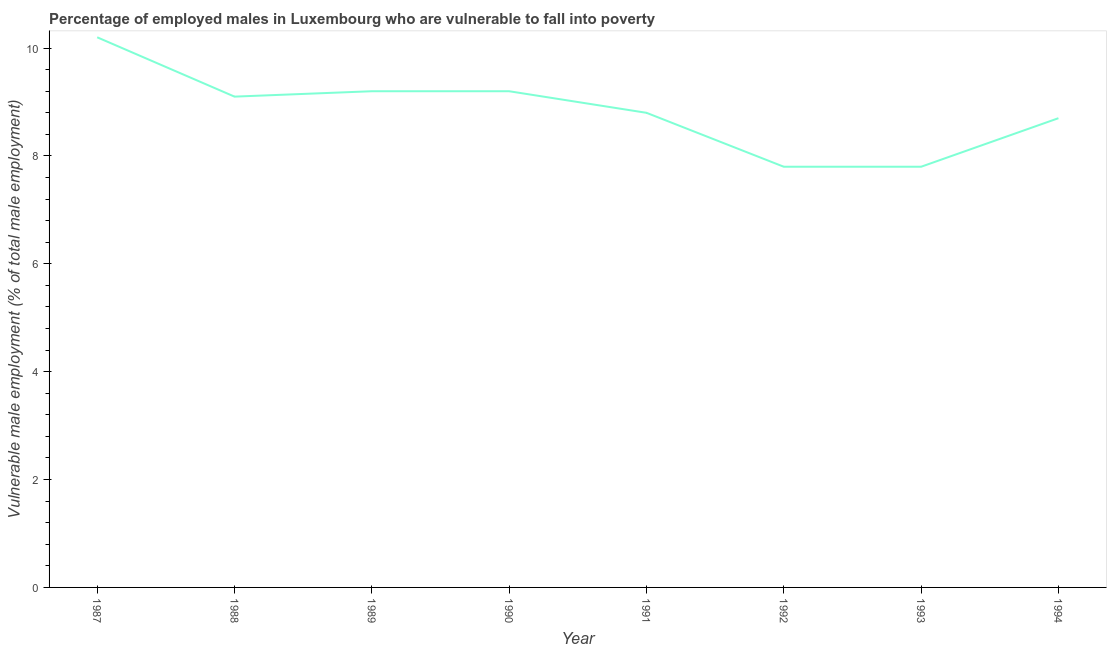What is the percentage of employed males who are vulnerable to fall into poverty in 1989?
Provide a short and direct response. 9.2. Across all years, what is the maximum percentage of employed males who are vulnerable to fall into poverty?
Ensure brevity in your answer.  10.2. Across all years, what is the minimum percentage of employed males who are vulnerable to fall into poverty?
Give a very brief answer. 7.8. In which year was the percentage of employed males who are vulnerable to fall into poverty maximum?
Provide a succinct answer. 1987. What is the sum of the percentage of employed males who are vulnerable to fall into poverty?
Your answer should be compact. 70.8. What is the difference between the percentage of employed males who are vulnerable to fall into poverty in 1990 and 1993?
Provide a short and direct response. 1.4. What is the average percentage of employed males who are vulnerable to fall into poverty per year?
Make the answer very short. 8.85. What is the median percentage of employed males who are vulnerable to fall into poverty?
Keep it short and to the point. 8.95. Do a majority of the years between 1994 and 1987 (inclusive) have percentage of employed males who are vulnerable to fall into poverty greater than 4.8 %?
Make the answer very short. Yes. What is the ratio of the percentage of employed males who are vulnerable to fall into poverty in 1989 to that in 1990?
Your response must be concise. 1. What is the difference between the highest and the second highest percentage of employed males who are vulnerable to fall into poverty?
Provide a succinct answer. 1. What is the difference between the highest and the lowest percentage of employed males who are vulnerable to fall into poverty?
Your answer should be compact. 2.4. In how many years, is the percentage of employed males who are vulnerable to fall into poverty greater than the average percentage of employed males who are vulnerable to fall into poverty taken over all years?
Your answer should be compact. 4. What is the difference between two consecutive major ticks on the Y-axis?
Your answer should be very brief. 2. Are the values on the major ticks of Y-axis written in scientific E-notation?
Your response must be concise. No. Does the graph contain any zero values?
Your answer should be compact. No. What is the title of the graph?
Keep it short and to the point. Percentage of employed males in Luxembourg who are vulnerable to fall into poverty. What is the label or title of the X-axis?
Ensure brevity in your answer.  Year. What is the label or title of the Y-axis?
Ensure brevity in your answer.  Vulnerable male employment (% of total male employment). What is the Vulnerable male employment (% of total male employment) of 1987?
Make the answer very short. 10.2. What is the Vulnerable male employment (% of total male employment) in 1988?
Your response must be concise. 9.1. What is the Vulnerable male employment (% of total male employment) in 1989?
Your answer should be very brief. 9.2. What is the Vulnerable male employment (% of total male employment) in 1990?
Make the answer very short. 9.2. What is the Vulnerable male employment (% of total male employment) in 1991?
Offer a very short reply. 8.8. What is the Vulnerable male employment (% of total male employment) in 1992?
Offer a very short reply. 7.8. What is the Vulnerable male employment (% of total male employment) of 1993?
Provide a short and direct response. 7.8. What is the Vulnerable male employment (% of total male employment) of 1994?
Offer a terse response. 8.7. What is the difference between the Vulnerable male employment (% of total male employment) in 1987 and 1988?
Your answer should be very brief. 1.1. What is the difference between the Vulnerable male employment (% of total male employment) in 1987 and 1989?
Make the answer very short. 1. What is the difference between the Vulnerable male employment (% of total male employment) in 1987 and 1990?
Offer a very short reply. 1. What is the difference between the Vulnerable male employment (% of total male employment) in 1987 and 1991?
Provide a short and direct response. 1.4. What is the difference between the Vulnerable male employment (% of total male employment) in 1987 and 1992?
Your response must be concise. 2.4. What is the difference between the Vulnerable male employment (% of total male employment) in 1987 and 1993?
Your response must be concise. 2.4. What is the difference between the Vulnerable male employment (% of total male employment) in 1987 and 1994?
Ensure brevity in your answer.  1.5. What is the difference between the Vulnerable male employment (% of total male employment) in 1988 and 1990?
Offer a very short reply. -0.1. What is the difference between the Vulnerable male employment (% of total male employment) in 1988 and 1991?
Your answer should be very brief. 0.3. What is the difference between the Vulnerable male employment (% of total male employment) in 1988 and 1992?
Your answer should be compact. 1.3. What is the difference between the Vulnerable male employment (% of total male employment) in 1988 and 1994?
Your response must be concise. 0.4. What is the difference between the Vulnerable male employment (% of total male employment) in 1989 and 1990?
Keep it short and to the point. 0. What is the difference between the Vulnerable male employment (% of total male employment) in 1989 and 1993?
Give a very brief answer. 1.4. What is the difference between the Vulnerable male employment (% of total male employment) in 1990 and 1992?
Offer a terse response. 1.4. What is the difference between the Vulnerable male employment (% of total male employment) in 1990 and 1993?
Your answer should be compact. 1.4. What is the difference between the Vulnerable male employment (% of total male employment) in 1991 and 1994?
Offer a terse response. 0.1. What is the ratio of the Vulnerable male employment (% of total male employment) in 1987 to that in 1988?
Your answer should be compact. 1.12. What is the ratio of the Vulnerable male employment (% of total male employment) in 1987 to that in 1989?
Offer a very short reply. 1.11. What is the ratio of the Vulnerable male employment (% of total male employment) in 1987 to that in 1990?
Your response must be concise. 1.11. What is the ratio of the Vulnerable male employment (% of total male employment) in 1987 to that in 1991?
Your response must be concise. 1.16. What is the ratio of the Vulnerable male employment (% of total male employment) in 1987 to that in 1992?
Provide a short and direct response. 1.31. What is the ratio of the Vulnerable male employment (% of total male employment) in 1987 to that in 1993?
Give a very brief answer. 1.31. What is the ratio of the Vulnerable male employment (% of total male employment) in 1987 to that in 1994?
Provide a short and direct response. 1.17. What is the ratio of the Vulnerable male employment (% of total male employment) in 1988 to that in 1989?
Offer a terse response. 0.99. What is the ratio of the Vulnerable male employment (% of total male employment) in 1988 to that in 1990?
Provide a succinct answer. 0.99. What is the ratio of the Vulnerable male employment (% of total male employment) in 1988 to that in 1991?
Give a very brief answer. 1.03. What is the ratio of the Vulnerable male employment (% of total male employment) in 1988 to that in 1992?
Offer a terse response. 1.17. What is the ratio of the Vulnerable male employment (% of total male employment) in 1988 to that in 1993?
Ensure brevity in your answer.  1.17. What is the ratio of the Vulnerable male employment (% of total male employment) in 1988 to that in 1994?
Offer a terse response. 1.05. What is the ratio of the Vulnerable male employment (% of total male employment) in 1989 to that in 1990?
Offer a terse response. 1. What is the ratio of the Vulnerable male employment (% of total male employment) in 1989 to that in 1991?
Offer a terse response. 1.04. What is the ratio of the Vulnerable male employment (% of total male employment) in 1989 to that in 1992?
Offer a very short reply. 1.18. What is the ratio of the Vulnerable male employment (% of total male employment) in 1989 to that in 1993?
Ensure brevity in your answer.  1.18. What is the ratio of the Vulnerable male employment (% of total male employment) in 1989 to that in 1994?
Provide a succinct answer. 1.06. What is the ratio of the Vulnerable male employment (% of total male employment) in 1990 to that in 1991?
Give a very brief answer. 1.04. What is the ratio of the Vulnerable male employment (% of total male employment) in 1990 to that in 1992?
Keep it short and to the point. 1.18. What is the ratio of the Vulnerable male employment (% of total male employment) in 1990 to that in 1993?
Your answer should be compact. 1.18. What is the ratio of the Vulnerable male employment (% of total male employment) in 1990 to that in 1994?
Keep it short and to the point. 1.06. What is the ratio of the Vulnerable male employment (% of total male employment) in 1991 to that in 1992?
Keep it short and to the point. 1.13. What is the ratio of the Vulnerable male employment (% of total male employment) in 1991 to that in 1993?
Your answer should be very brief. 1.13. What is the ratio of the Vulnerable male employment (% of total male employment) in 1992 to that in 1993?
Offer a very short reply. 1. What is the ratio of the Vulnerable male employment (% of total male employment) in 1992 to that in 1994?
Provide a short and direct response. 0.9. What is the ratio of the Vulnerable male employment (% of total male employment) in 1993 to that in 1994?
Make the answer very short. 0.9. 